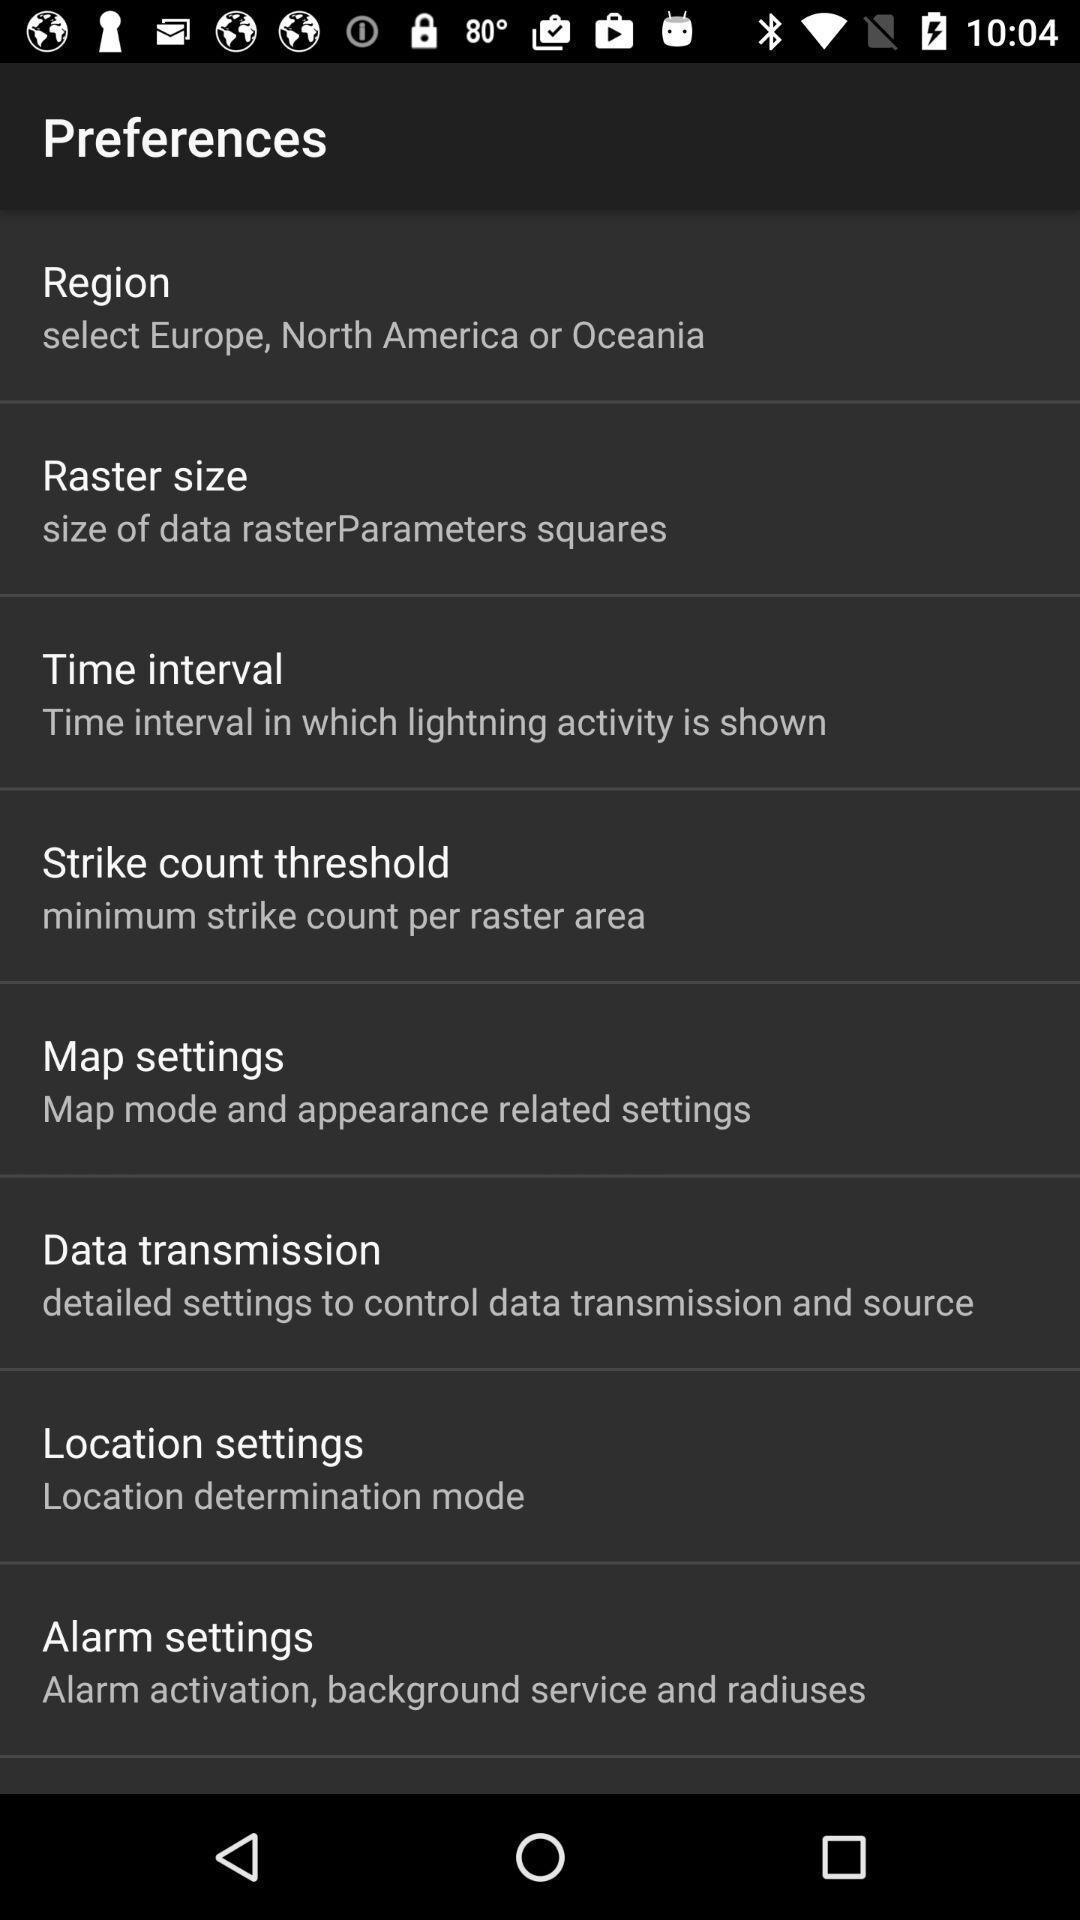Describe the visual elements of this screenshot. Page displaying settings information of a map application. 